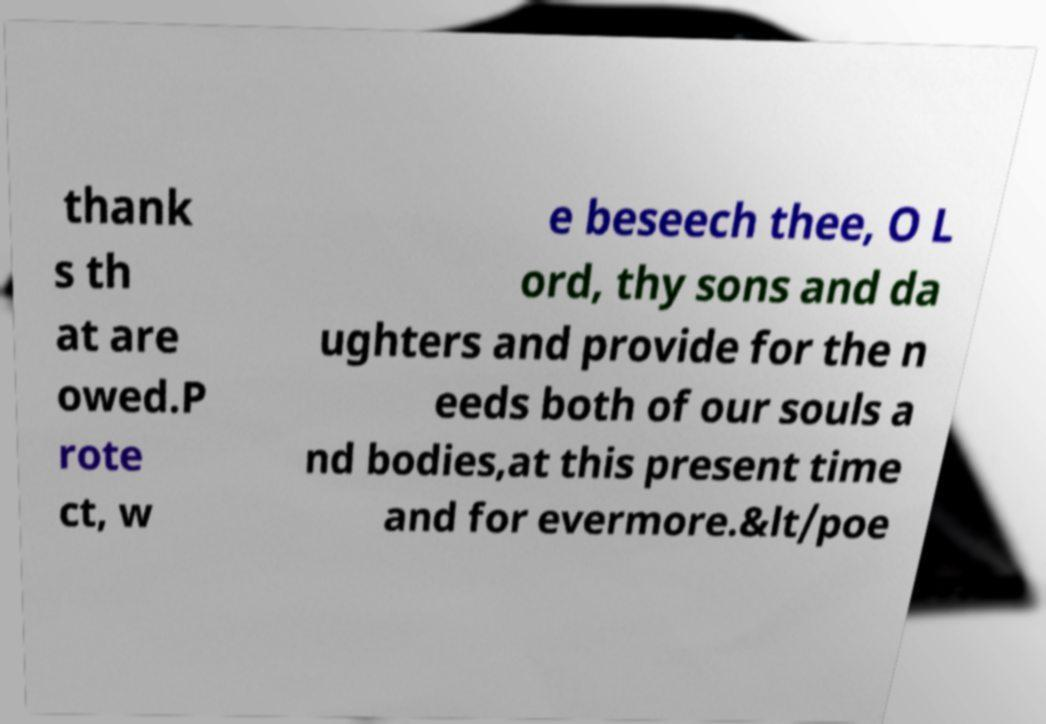Can you accurately transcribe the text from the provided image for me? thank s th at are owed.P rote ct, w e beseech thee, O L ord, thy sons and da ughters and provide for the n eeds both of our souls a nd bodies,at this present time and for evermore.&lt/poe 